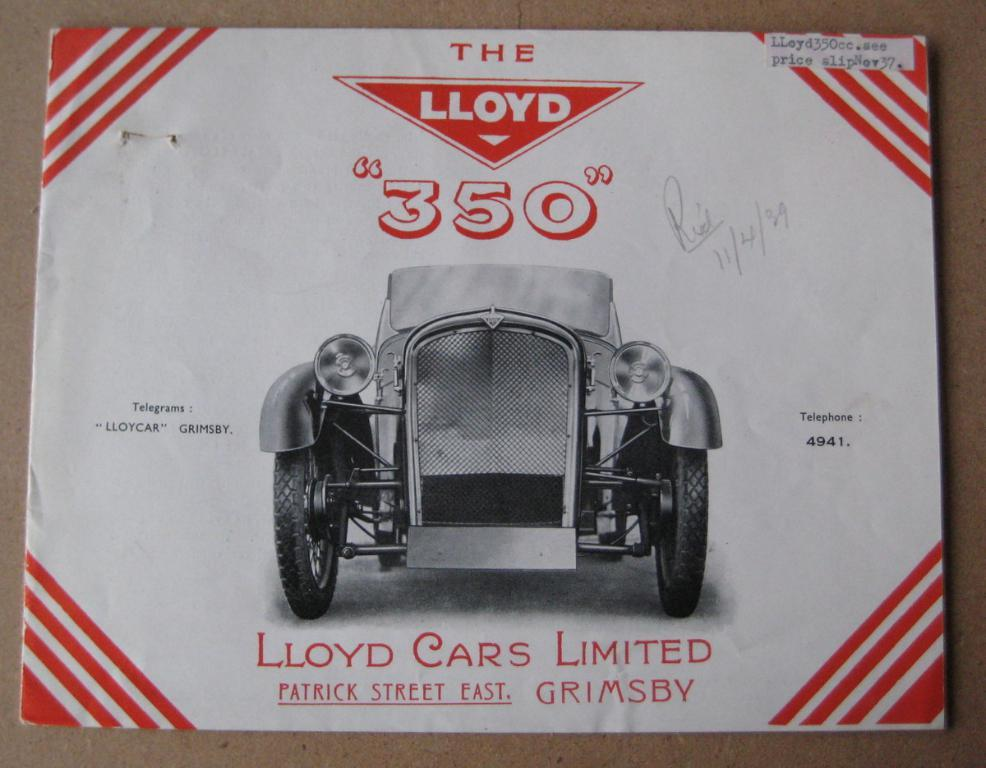What object is visible in the image? There is a book in the image. Where is the book located? The book is on a table. What is depicted in the book? There is a picture of a car in the book. What type of linen can be seen draped over the building in the image? There is no building or linen present in the image; it only features a book with a picture of a car. 